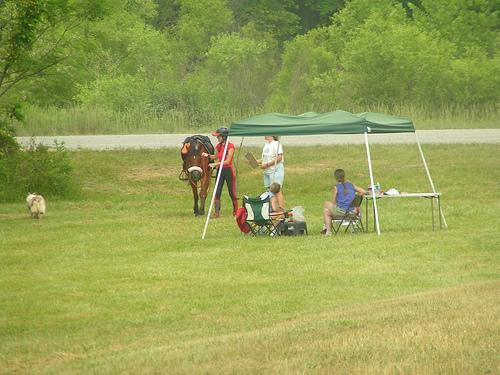What sport is being played?
Keep it brief. Polo. What number of people are in the grass?
Concise answer only. 4. Are there girls on the field?
Be succinct. Yes. What color is dominant?
Concise answer only. Green. 